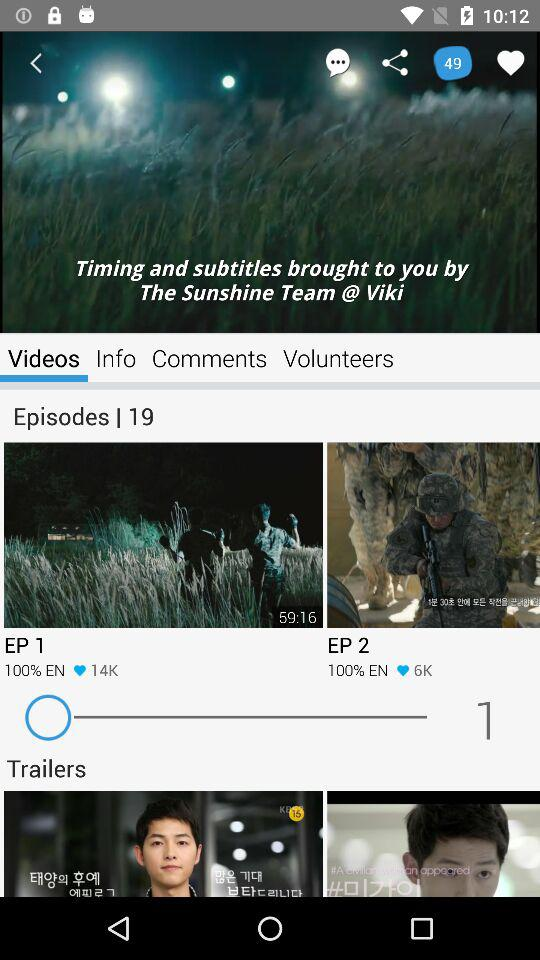How many episodes are there?
Answer the question using a single word or phrase. 19 